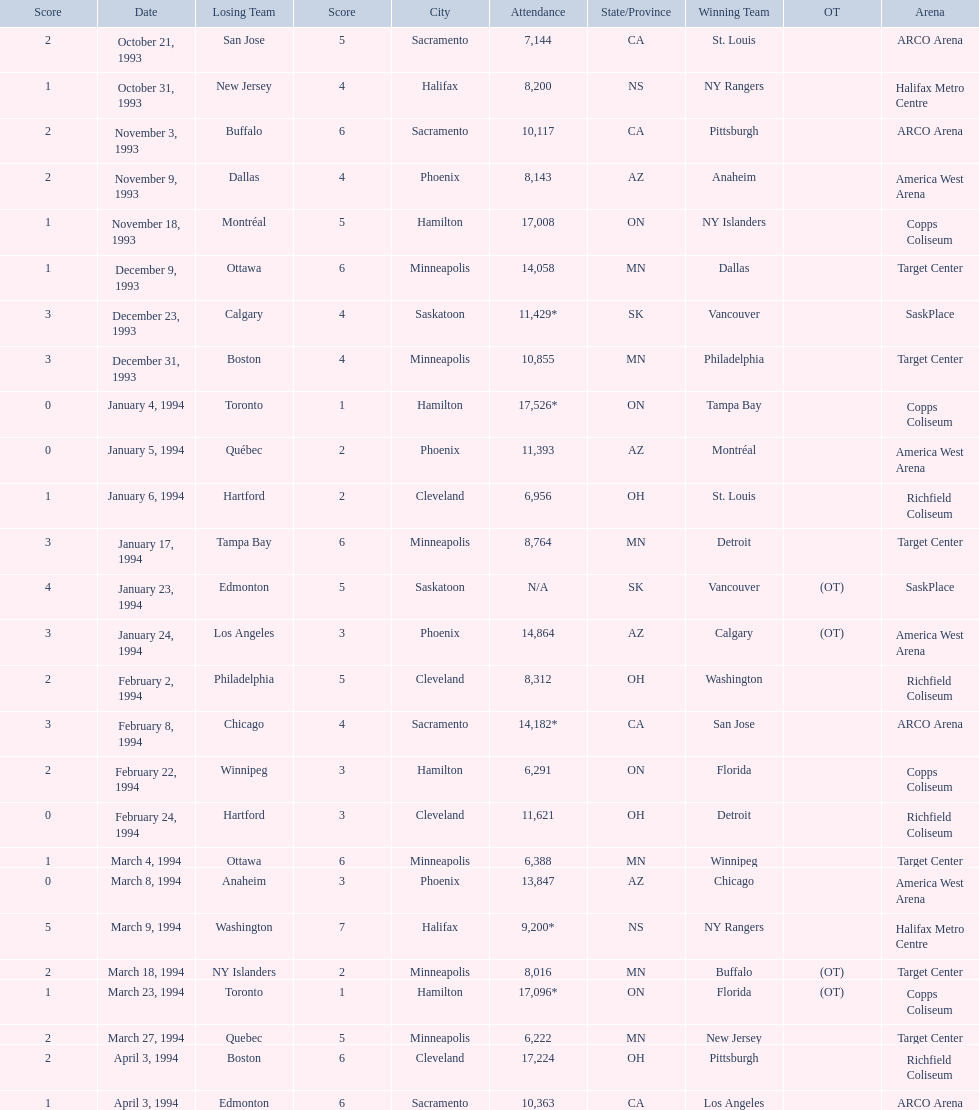Which was the highest attendance for a game? 17,526*. What was the date of the game with an attendance of 17,526? January 4, 1994. 